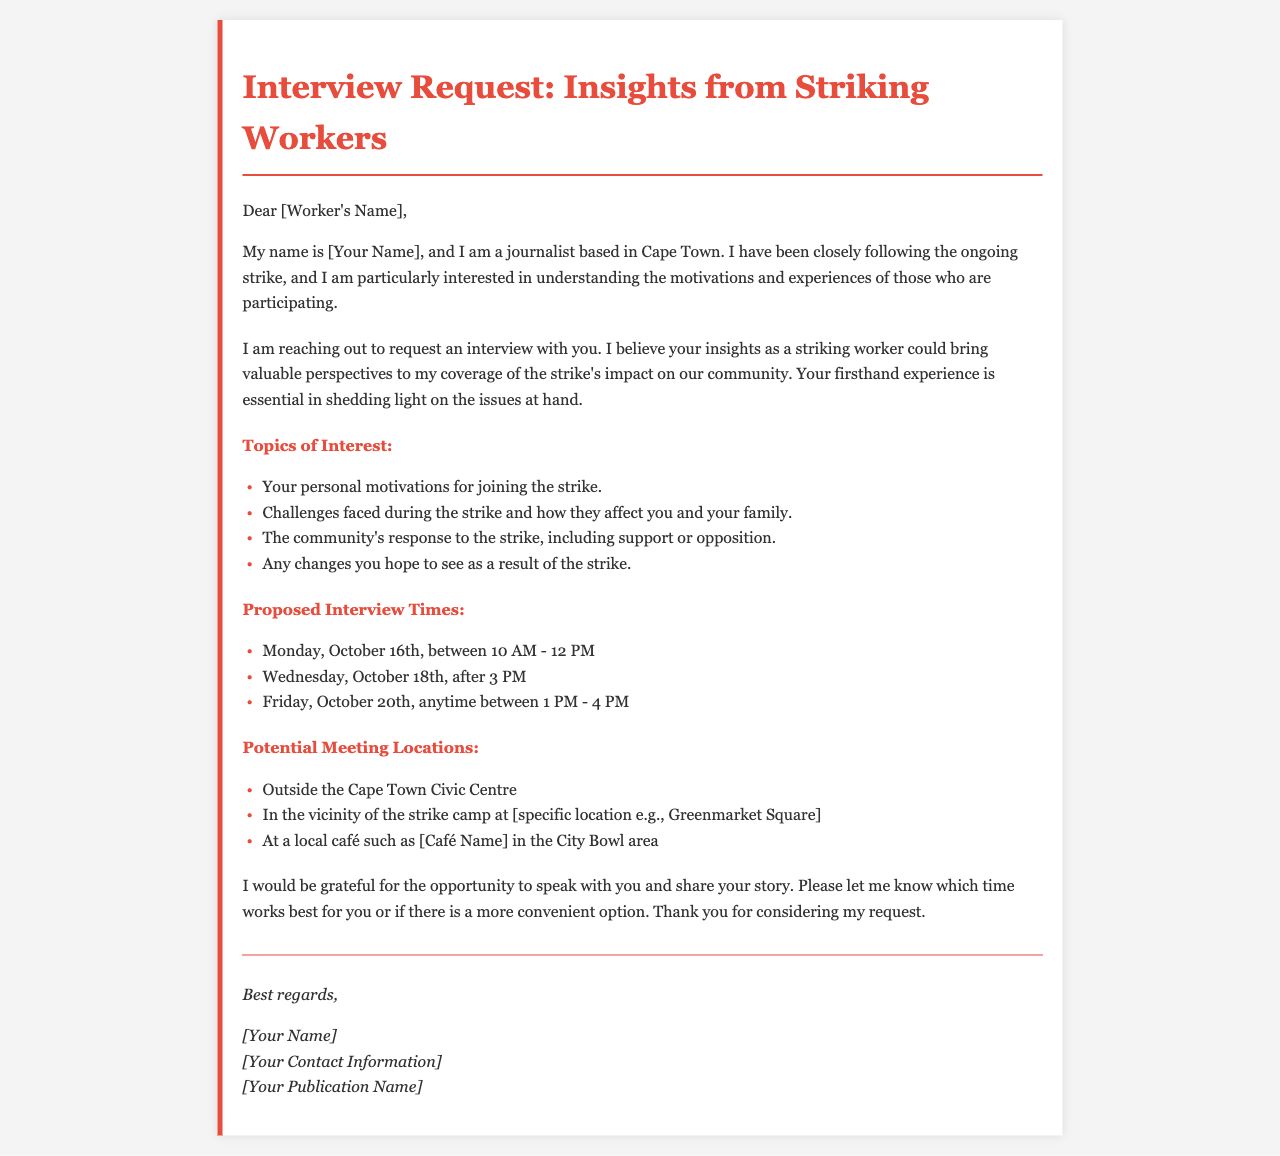what is the subject of the email? The subject of the email is indicated in the title of the document, which focuses on an interview request with insights from striking workers.
Answer: Interview Request: Insights from Striking Workers who is the sender of the email? The sender's identity is referred to as "[Your Name]" indicating it is a placeholder for the actual name.
Answer: [Your Name] what are the proposed interview times? The proposed interview times are listed in the document, suggesting specific dates and time ranges for the interview.
Answer: Monday, October 16th, between 10 AM - 12 PM; Wednesday, October 18th, after 3 PM; Friday, October 20th, anytime between 1 PM - 4 PM what topics of interest will be discussed in the interview? The topics of interest highlight key issues that the sender wants to understand from the striking worker's perspective.
Answer: Your personal motivations for joining the strike; Challenges faced during the strike and how they affect you and your family; The community's response to the strike, including support or opposition; Any changes you hope to see as a result of the strike where is one potential meeting location? The document lists several potential meeting locations, providing options suitable for the interview.
Answer: Outside the Cape Town Civic Centre what is the primary motivation for the interview request? The sender aims to understand the motivations and experiences of striking workers to provide valuable perspectives in their coverage.
Answer: Understanding the motivations and experiences of striking workers how does the sender sign off the email? The sender's sign-off includes a polite ending, thanking the recipient for considering the request and providing contact details.
Answer: Best regards, [Your Name] [Your Contact Information] [Your Publication Name] what role does the striking worker play in the document? The striking worker is the proposed interviewee mentioned as crucial for providing insights about the strike's impact.
Answer: Interviewee what type of document is this? The structure and content indicate that this is a formal email communication.
Answer: Formal email 